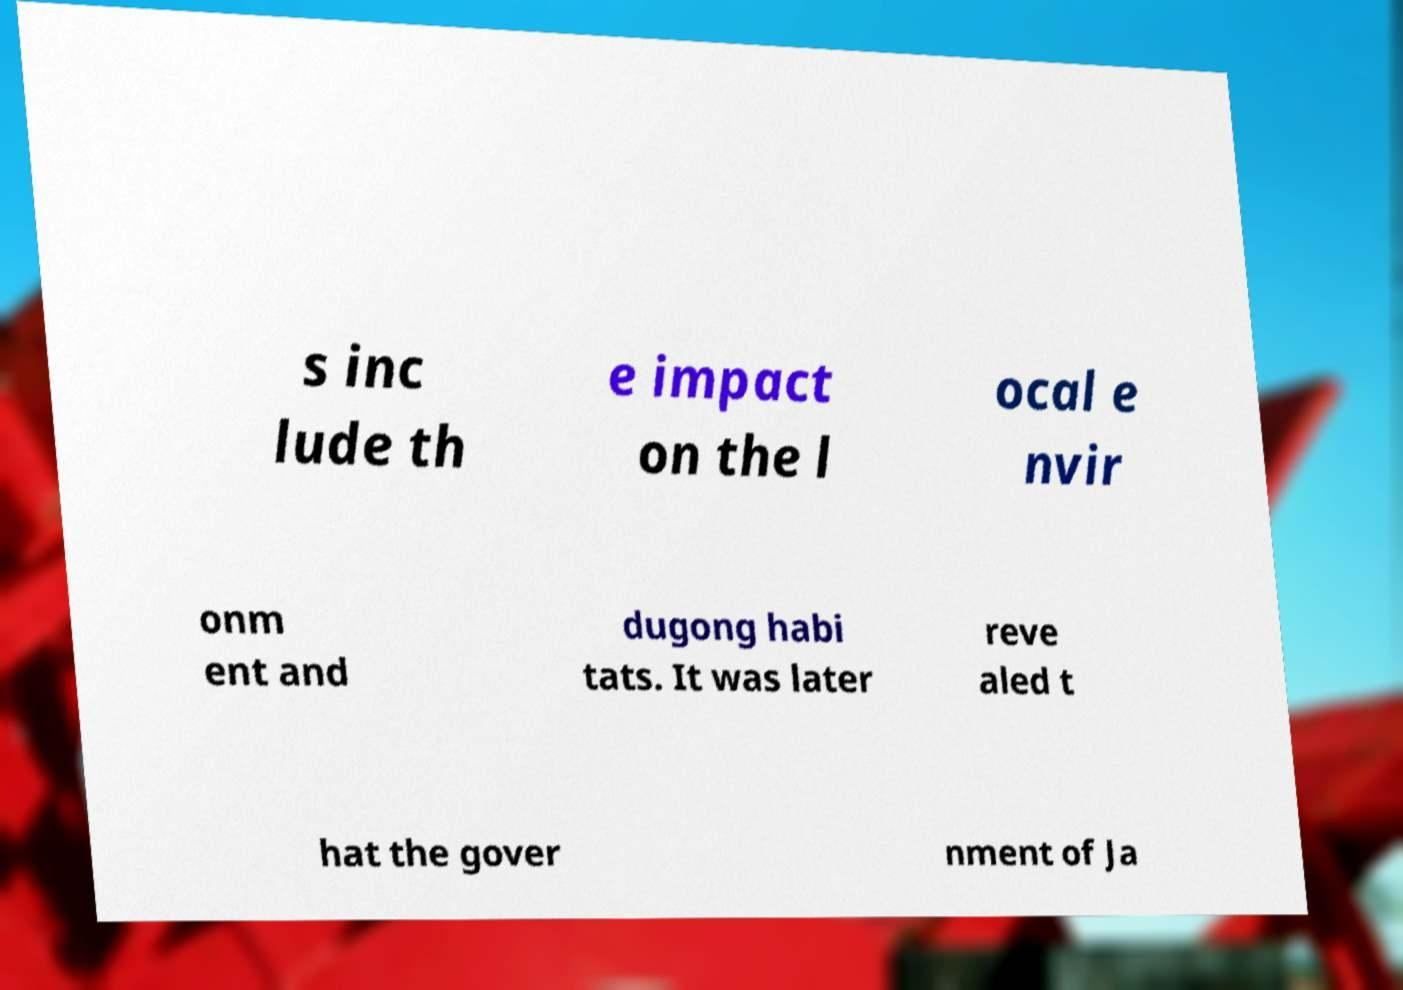There's text embedded in this image that I need extracted. Can you transcribe it verbatim? s inc lude th e impact on the l ocal e nvir onm ent and dugong habi tats. It was later reve aled t hat the gover nment of Ja 